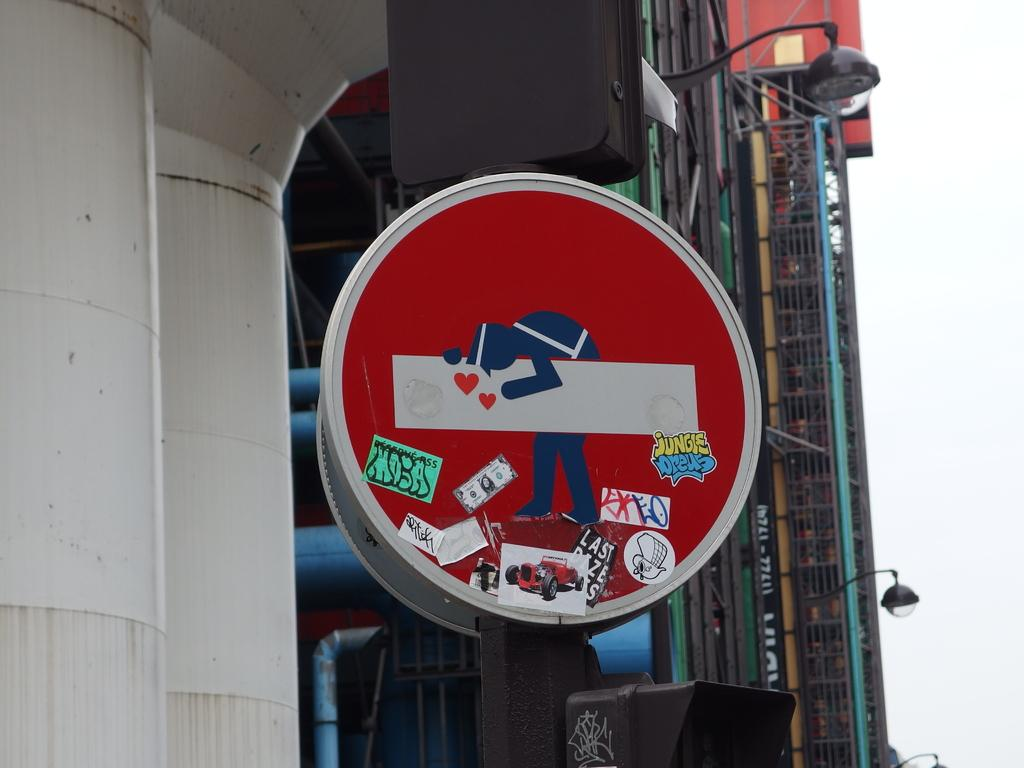<image>
Provide a brief description of the given image. a sign that has a 1 dollar mark on it 